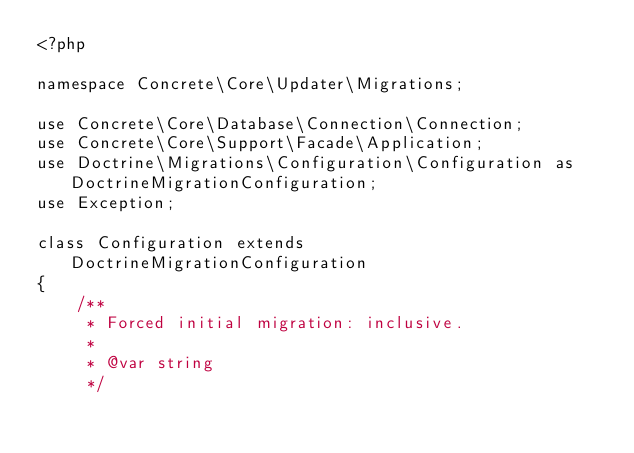<code> <loc_0><loc_0><loc_500><loc_500><_PHP_><?php

namespace Concrete\Core\Updater\Migrations;

use Concrete\Core\Database\Connection\Connection;
use Concrete\Core\Support\Facade\Application;
use Doctrine\Migrations\Configuration\Configuration as DoctrineMigrationConfiguration;
use Exception;

class Configuration extends DoctrineMigrationConfiguration
{
    /**
     * Forced initial migration: inclusive.
     *
     * @var string
     */</code> 